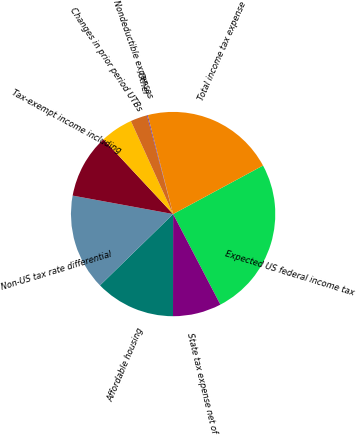Convert chart. <chart><loc_0><loc_0><loc_500><loc_500><pie_chart><fcel>Expected US federal income tax<fcel>State tax expense net of<fcel>Affordable housing<fcel>Non-US tax rate differential<fcel>Tax-exempt income including<fcel>Changes in prior period UTBs<fcel>Nondeductible expenses<fcel>Other<fcel>Total income tax expense<nl><fcel>25.22%<fcel>7.67%<fcel>12.68%<fcel>15.19%<fcel>10.17%<fcel>5.16%<fcel>2.65%<fcel>0.14%<fcel>21.11%<nl></chart> 